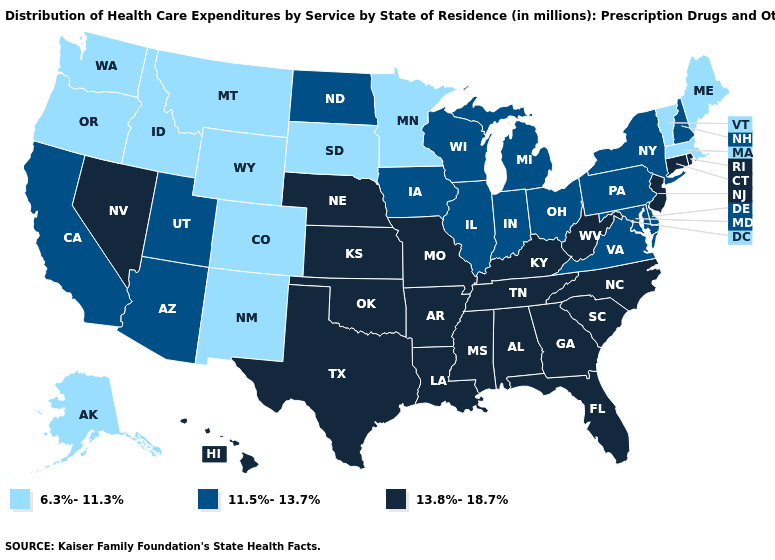Name the states that have a value in the range 11.5%-13.7%?
Concise answer only. Arizona, California, Delaware, Illinois, Indiana, Iowa, Maryland, Michigan, New Hampshire, New York, North Dakota, Ohio, Pennsylvania, Utah, Virginia, Wisconsin. Does Texas have the highest value in the USA?
Give a very brief answer. Yes. Does Tennessee have the same value as New York?
Quick response, please. No. Does Maryland have the lowest value in the South?
Be succinct. Yes. Which states hav the highest value in the MidWest?
Give a very brief answer. Kansas, Missouri, Nebraska. Does Idaho have the same value as Missouri?
Be succinct. No. What is the value of Rhode Island?
Quick response, please. 13.8%-18.7%. What is the value of Oregon?
Be succinct. 6.3%-11.3%. Name the states that have a value in the range 6.3%-11.3%?
Give a very brief answer. Alaska, Colorado, Idaho, Maine, Massachusetts, Minnesota, Montana, New Mexico, Oregon, South Dakota, Vermont, Washington, Wyoming. What is the value of Idaho?
Be succinct. 6.3%-11.3%. Does Nebraska have the highest value in the MidWest?
Short answer required. Yes. What is the value of South Dakota?
Answer briefly. 6.3%-11.3%. Name the states that have a value in the range 11.5%-13.7%?
Write a very short answer. Arizona, California, Delaware, Illinois, Indiana, Iowa, Maryland, Michigan, New Hampshire, New York, North Dakota, Ohio, Pennsylvania, Utah, Virginia, Wisconsin. Does Illinois have the lowest value in the MidWest?
Answer briefly. No. What is the value of California?
Keep it brief. 11.5%-13.7%. 